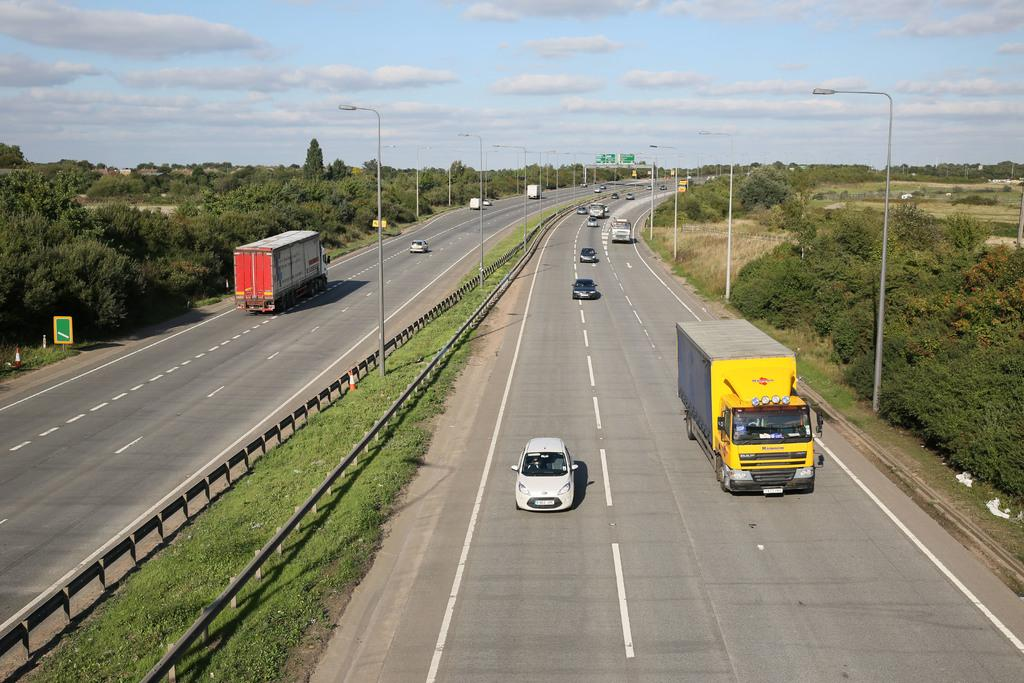What is the main feature of the image? There is a road in the image. What is happening on the road? There are vehicles on the road. What can be seen illuminating the road at night? Street lights are visible in the image. What type of natural elements are present in the image? There are trees in the image. What can be seen in the background of the image? The sky is visible in the background of the image, and there are clouds in the sky. How many cacti can be seen growing along the road in the image? There are no cacti visible in the image; it features a road with vehicles, street lights, trees, and a sky with clouds. What type of acoustics can be heard from the vehicles in the image? The image is a still picture and does not provide any auditory information, so it is impossible to determine the acoustics of the vehicles. 